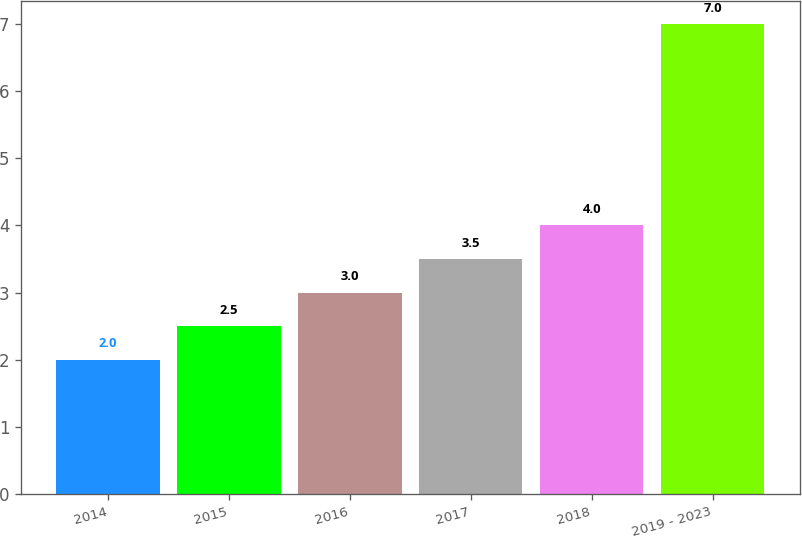Convert chart to OTSL. <chart><loc_0><loc_0><loc_500><loc_500><bar_chart><fcel>2014<fcel>2015<fcel>2016<fcel>2017<fcel>2018<fcel>2019 - 2023<nl><fcel>2<fcel>2.5<fcel>3<fcel>3.5<fcel>4<fcel>7<nl></chart> 